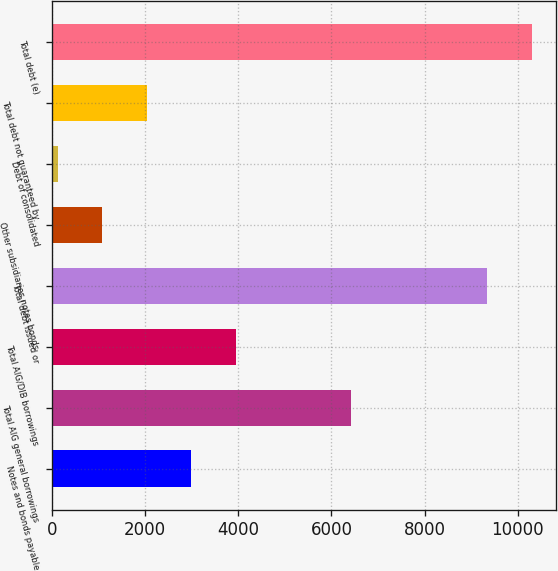<chart> <loc_0><loc_0><loc_500><loc_500><bar_chart><fcel>Notes and bonds payable<fcel>Total AIG general borrowings<fcel>Total AIG/DIB borrowings<fcel>Total debt issued or<fcel>Other subsidiaries notes bonds<fcel>Debt of consolidated<fcel>Total debt not guaranteed by<fcel>Total debt (e)<nl><fcel>2991.3<fcel>6422<fcel>3946.4<fcel>9344<fcel>1081.1<fcel>126<fcel>2036.2<fcel>10299.1<nl></chart> 